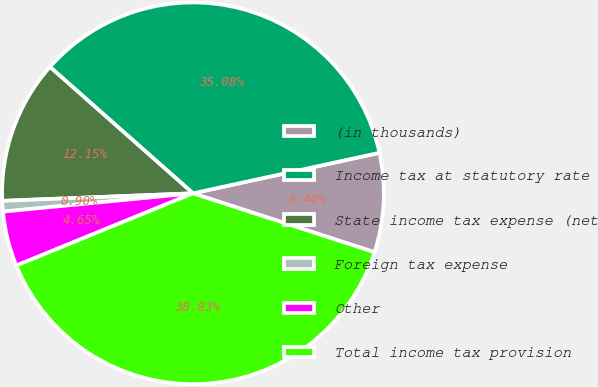Convert chart to OTSL. <chart><loc_0><loc_0><loc_500><loc_500><pie_chart><fcel>(in thousands)<fcel>Income tax at statutory rate<fcel>State income tax expense (net<fcel>Foreign tax expense<fcel>Other<fcel>Total income tax provision<nl><fcel>8.4%<fcel>35.08%<fcel>12.15%<fcel>0.9%<fcel>4.65%<fcel>38.83%<nl></chart> 